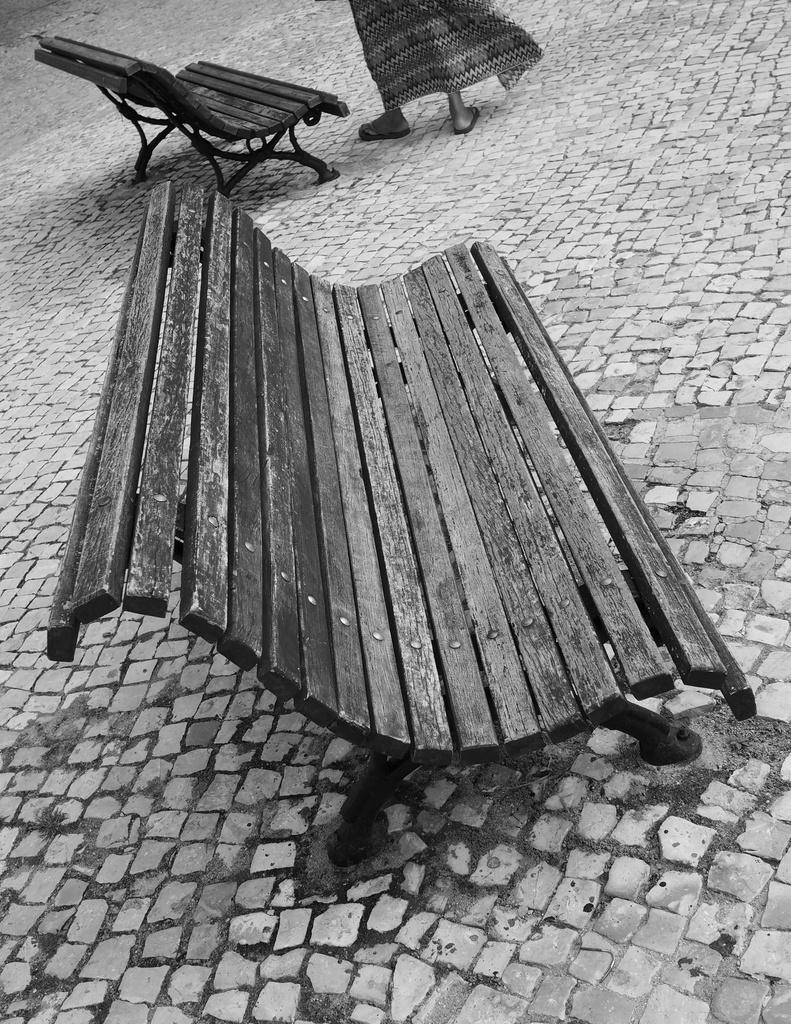What is the color scheme of the image? The image is black and white. How many benches can be seen in the image? There are two benches in the image. Can you describe any human presence in the image? A person's legs are visible in the image. What type of tank is visible in the image? There is no tank present in the image. How many friends are sitting on the benches in the image? The image does not show any friends sitting on the benches, as only a person's legs are visible. 